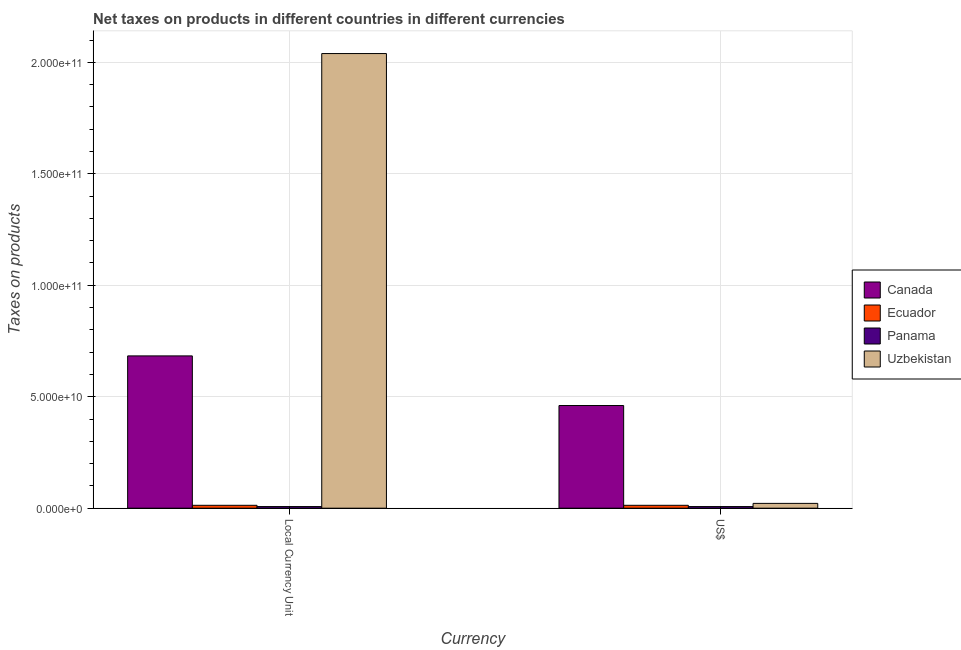How many bars are there on the 1st tick from the left?
Make the answer very short. 4. What is the label of the 1st group of bars from the left?
Give a very brief answer. Local Currency Unit. What is the net taxes in us$ in Canada?
Ensure brevity in your answer.  4.60e+1. Across all countries, what is the maximum net taxes in constant 2005 us$?
Make the answer very short. 2.04e+11. Across all countries, what is the minimum net taxes in us$?
Your response must be concise. 7.25e+08. In which country was the net taxes in constant 2005 us$ maximum?
Provide a short and direct response. Uzbekistan. In which country was the net taxes in constant 2005 us$ minimum?
Offer a very short reply. Panama. What is the total net taxes in us$ in the graph?
Keep it short and to the point. 5.02e+1. What is the difference between the net taxes in constant 2005 us$ in Panama and that in Ecuador?
Make the answer very short. -5.68e+08. What is the difference between the net taxes in us$ in Canada and the net taxes in constant 2005 us$ in Panama?
Your response must be concise. 4.53e+1. What is the average net taxes in us$ per country?
Offer a terse response. 1.26e+1. What is the difference between the net taxes in us$ and net taxes in constant 2005 us$ in Uzbekistan?
Your answer should be compact. -2.02e+11. In how many countries, is the net taxes in us$ greater than 160000000000 units?
Provide a succinct answer. 0. What is the ratio of the net taxes in constant 2005 us$ in Panama to that in Ecuador?
Give a very brief answer. 0.56. What does the 2nd bar from the left in US$ represents?
Keep it short and to the point. Ecuador. What does the 4th bar from the right in Local Currency Unit represents?
Offer a terse response. Canada. Are all the bars in the graph horizontal?
Offer a very short reply. No. What is the difference between two consecutive major ticks on the Y-axis?
Your answer should be compact. 5.00e+1. Are the values on the major ticks of Y-axis written in scientific E-notation?
Your answer should be very brief. Yes. Where does the legend appear in the graph?
Your answer should be very brief. Center right. How are the legend labels stacked?
Give a very brief answer. Vertical. What is the title of the graph?
Provide a short and direct response. Net taxes on products in different countries in different currencies. What is the label or title of the X-axis?
Give a very brief answer. Currency. What is the label or title of the Y-axis?
Offer a terse response. Taxes on products. What is the Taxes on products in Canada in Local Currency Unit?
Make the answer very short. 6.83e+1. What is the Taxes on products of Ecuador in Local Currency Unit?
Keep it short and to the point. 1.29e+09. What is the Taxes on products in Panama in Local Currency Unit?
Keep it short and to the point. 7.25e+08. What is the Taxes on products in Uzbekistan in Local Currency Unit?
Keep it short and to the point. 2.04e+11. What is the Taxes on products in Canada in US$?
Provide a succinct answer. 4.60e+1. What is the Taxes on products in Ecuador in US$?
Your answer should be very brief. 1.29e+09. What is the Taxes on products in Panama in US$?
Your answer should be very brief. 7.25e+08. What is the Taxes on products of Uzbekistan in US$?
Your response must be concise. 2.16e+09. Across all Currency, what is the maximum Taxes on products in Canada?
Your answer should be very brief. 6.83e+1. Across all Currency, what is the maximum Taxes on products in Ecuador?
Offer a very short reply. 1.29e+09. Across all Currency, what is the maximum Taxes on products of Panama?
Your answer should be very brief. 7.25e+08. Across all Currency, what is the maximum Taxes on products of Uzbekistan?
Offer a terse response. 2.04e+11. Across all Currency, what is the minimum Taxes on products in Canada?
Your response must be concise. 4.60e+1. Across all Currency, what is the minimum Taxes on products in Ecuador?
Give a very brief answer. 1.29e+09. Across all Currency, what is the minimum Taxes on products in Panama?
Offer a terse response. 7.25e+08. Across all Currency, what is the minimum Taxes on products in Uzbekistan?
Your answer should be very brief. 2.16e+09. What is the total Taxes on products in Canada in the graph?
Give a very brief answer. 1.14e+11. What is the total Taxes on products of Ecuador in the graph?
Ensure brevity in your answer.  2.59e+09. What is the total Taxes on products in Panama in the graph?
Give a very brief answer. 1.45e+09. What is the total Taxes on products in Uzbekistan in the graph?
Offer a very short reply. 2.06e+11. What is the difference between the Taxes on products in Canada in Local Currency Unit and that in US$?
Your answer should be compact. 2.23e+1. What is the difference between the Taxes on products in Ecuador in Local Currency Unit and that in US$?
Offer a terse response. -6.47e+05. What is the difference between the Taxes on products in Panama in Local Currency Unit and that in US$?
Offer a terse response. 0. What is the difference between the Taxes on products of Uzbekistan in Local Currency Unit and that in US$?
Keep it short and to the point. 2.02e+11. What is the difference between the Taxes on products in Canada in Local Currency Unit and the Taxes on products in Ecuador in US$?
Offer a terse response. 6.70e+1. What is the difference between the Taxes on products of Canada in Local Currency Unit and the Taxes on products of Panama in US$?
Your answer should be compact. 6.76e+1. What is the difference between the Taxes on products in Canada in Local Currency Unit and the Taxes on products in Uzbekistan in US$?
Provide a succinct answer. 6.62e+1. What is the difference between the Taxes on products in Ecuador in Local Currency Unit and the Taxes on products in Panama in US$?
Your answer should be compact. 5.68e+08. What is the difference between the Taxes on products of Ecuador in Local Currency Unit and the Taxes on products of Uzbekistan in US$?
Keep it short and to the point. -8.66e+08. What is the difference between the Taxes on products in Panama in Local Currency Unit and the Taxes on products in Uzbekistan in US$?
Offer a very short reply. -1.43e+09. What is the average Taxes on products of Canada per Currency?
Provide a succinct answer. 5.72e+1. What is the average Taxes on products of Ecuador per Currency?
Offer a very short reply. 1.29e+09. What is the average Taxes on products of Panama per Currency?
Make the answer very short. 7.25e+08. What is the average Taxes on products in Uzbekistan per Currency?
Offer a terse response. 1.03e+11. What is the difference between the Taxes on products in Canada and Taxes on products in Ecuador in Local Currency Unit?
Give a very brief answer. 6.70e+1. What is the difference between the Taxes on products of Canada and Taxes on products of Panama in Local Currency Unit?
Ensure brevity in your answer.  6.76e+1. What is the difference between the Taxes on products in Canada and Taxes on products in Uzbekistan in Local Currency Unit?
Your answer should be compact. -1.36e+11. What is the difference between the Taxes on products of Ecuador and Taxes on products of Panama in Local Currency Unit?
Ensure brevity in your answer.  5.68e+08. What is the difference between the Taxes on products in Ecuador and Taxes on products in Uzbekistan in Local Currency Unit?
Give a very brief answer. -2.03e+11. What is the difference between the Taxes on products of Panama and Taxes on products of Uzbekistan in Local Currency Unit?
Keep it short and to the point. -2.03e+11. What is the difference between the Taxes on products of Canada and Taxes on products of Ecuador in US$?
Your answer should be compact. 4.48e+1. What is the difference between the Taxes on products in Canada and Taxes on products in Panama in US$?
Offer a very short reply. 4.53e+1. What is the difference between the Taxes on products in Canada and Taxes on products in Uzbekistan in US$?
Make the answer very short. 4.39e+1. What is the difference between the Taxes on products of Ecuador and Taxes on products of Panama in US$?
Your answer should be very brief. 5.68e+08. What is the difference between the Taxes on products of Ecuador and Taxes on products of Uzbekistan in US$?
Your response must be concise. -8.65e+08. What is the difference between the Taxes on products of Panama and Taxes on products of Uzbekistan in US$?
Provide a succinct answer. -1.43e+09. What is the ratio of the Taxes on products in Canada in Local Currency Unit to that in US$?
Keep it short and to the point. 1.48. What is the ratio of the Taxes on products of Ecuador in Local Currency Unit to that in US$?
Keep it short and to the point. 1. What is the ratio of the Taxes on products in Uzbekistan in Local Currency Unit to that in US$?
Offer a very short reply. 94.48. What is the difference between the highest and the second highest Taxes on products in Canada?
Your response must be concise. 2.23e+1. What is the difference between the highest and the second highest Taxes on products in Ecuador?
Ensure brevity in your answer.  6.47e+05. What is the difference between the highest and the second highest Taxes on products in Uzbekistan?
Provide a short and direct response. 2.02e+11. What is the difference between the highest and the lowest Taxes on products of Canada?
Ensure brevity in your answer.  2.23e+1. What is the difference between the highest and the lowest Taxes on products of Ecuador?
Offer a terse response. 6.47e+05. What is the difference between the highest and the lowest Taxes on products in Panama?
Your answer should be very brief. 0. What is the difference between the highest and the lowest Taxes on products of Uzbekistan?
Provide a short and direct response. 2.02e+11. 